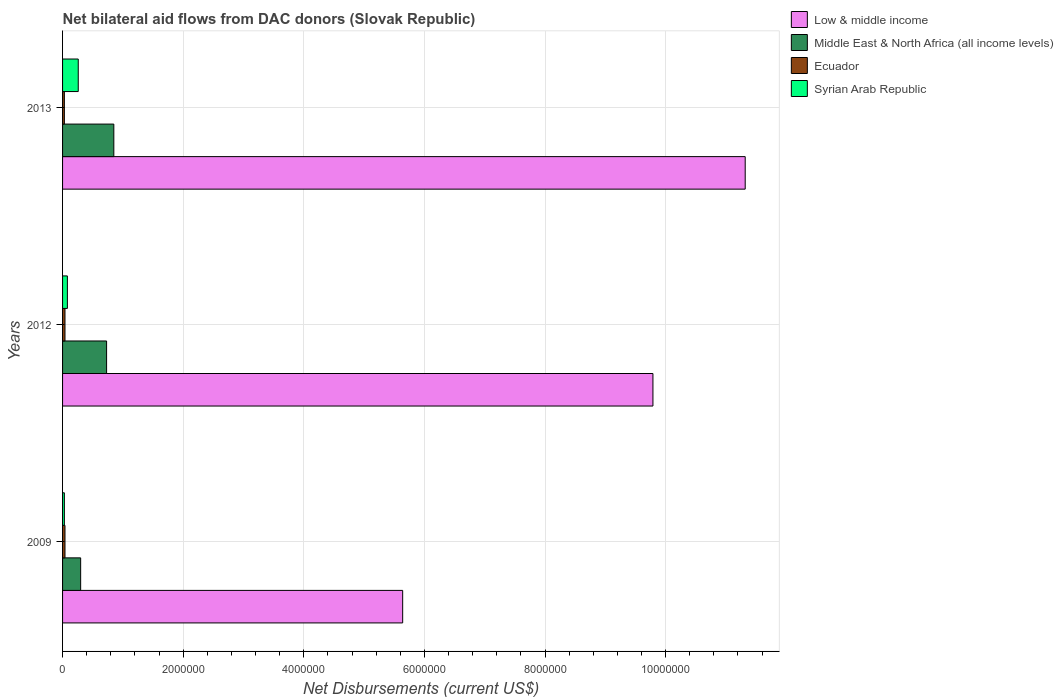How many different coloured bars are there?
Your answer should be compact. 4. Are the number of bars per tick equal to the number of legend labels?
Make the answer very short. Yes. How many bars are there on the 1st tick from the top?
Offer a very short reply. 4. What is the label of the 2nd group of bars from the top?
Your answer should be very brief. 2012. In how many cases, is the number of bars for a given year not equal to the number of legend labels?
Your answer should be very brief. 0. What is the net bilateral aid flows in Low & middle income in 2009?
Provide a short and direct response. 5.64e+06. Across all years, what is the minimum net bilateral aid flows in Syrian Arab Republic?
Make the answer very short. 3.00e+04. What is the total net bilateral aid flows in Ecuador in the graph?
Offer a terse response. 1.10e+05. What is the difference between the net bilateral aid flows in Syrian Arab Republic in 2009 and that in 2013?
Offer a terse response. -2.30e+05. What is the average net bilateral aid flows in Ecuador per year?
Provide a short and direct response. 3.67e+04. In the year 2012, what is the difference between the net bilateral aid flows in Ecuador and net bilateral aid flows in Middle East & North Africa (all income levels)?
Ensure brevity in your answer.  -6.90e+05. What is the ratio of the net bilateral aid flows in Ecuador in 2009 to that in 2012?
Provide a succinct answer. 1. Is the difference between the net bilateral aid flows in Ecuador in 2009 and 2012 greater than the difference between the net bilateral aid flows in Middle East & North Africa (all income levels) in 2009 and 2012?
Your answer should be very brief. Yes. What is the difference between the highest and the second highest net bilateral aid flows in Low & middle income?
Provide a succinct answer. 1.53e+06. What is the difference between the highest and the lowest net bilateral aid flows in Low & middle income?
Give a very brief answer. 5.68e+06. Is the sum of the net bilateral aid flows in Low & middle income in 2009 and 2013 greater than the maximum net bilateral aid flows in Syrian Arab Republic across all years?
Your answer should be compact. Yes. What does the 1st bar from the top in 2013 represents?
Your response must be concise. Syrian Arab Republic. What does the 3rd bar from the bottom in 2009 represents?
Offer a terse response. Ecuador. What is the difference between two consecutive major ticks on the X-axis?
Your answer should be compact. 2.00e+06. Does the graph contain any zero values?
Offer a very short reply. No. How many legend labels are there?
Offer a very short reply. 4. How are the legend labels stacked?
Give a very brief answer. Vertical. What is the title of the graph?
Keep it short and to the point. Net bilateral aid flows from DAC donors (Slovak Republic). What is the label or title of the X-axis?
Provide a succinct answer. Net Disbursements (current US$). What is the label or title of the Y-axis?
Your answer should be very brief. Years. What is the Net Disbursements (current US$) in Low & middle income in 2009?
Provide a succinct answer. 5.64e+06. What is the Net Disbursements (current US$) of Syrian Arab Republic in 2009?
Provide a succinct answer. 3.00e+04. What is the Net Disbursements (current US$) in Low & middle income in 2012?
Your answer should be very brief. 9.79e+06. What is the Net Disbursements (current US$) in Middle East & North Africa (all income levels) in 2012?
Your answer should be compact. 7.30e+05. What is the Net Disbursements (current US$) of Low & middle income in 2013?
Offer a terse response. 1.13e+07. What is the Net Disbursements (current US$) of Middle East & North Africa (all income levels) in 2013?
Offer a very short reply. 8.50e+05. What is the Net Disbursements (current US$) in Syrian Arab Republic in 2013?
Provide a short and direct response. 2.60e+05. Across all years, what is the maximum Net Disbursements (current US$) in Low & middle income?
Provide a short and direct response. 1.13e+07. Across all years, what is the maximum Net Disbursements (current US$) of Middle East & North Africa (all income levels)?
Keep it short and to the point. 8.50e+05. Across all years, what is the minimum Net Disbursements (current US$) in Low & middle income?
Offer a very short reply. 5.64e+06. Across all years, what is the minimum Net Disbursements (current US$) in Middle East & North Africa (all income levels)?
Keep it short and to the point. 3.00e+05. What is the total Net Disbursements (current US$) in Low & middle income in the graph?
Your answer should be compact. 2.68e+07. What is the total Net Disbursements (current US$) in Middle East & North Africa (all income levels) in the graph?
Offer a terse response. 1.88e+06. What is the total Net Disbursements (current US$) in Syrian Arab Republic in the graph?
Offer a very short reply. 3.70e+05. What is the difference between the Net Disbursements (current US$) in Low & middle income in 2009 and that in 2012?
Offer a terse response. -4.15e+06. What is the difference between the Net Disbursements (current US$) in Middle East & North Africa (all income levels) in 2009 and that in 2012?
Your answer should be compact. -4.30e+05. What is the difference between the Net Disbursements (current US$) of Ecuador in 2009 and that in 2012?
Your answer should be very brief. 0. What is the difference between the Net Disbursements (current US$) in Low & middle income in 2009 and that in 2013?
Offer a terse response. -5.68e+06. What is the difference between the Net Disbursements (current US$) of Middle East & North Africa (all income levels) in 2009 and that in 2013?
Provide a short and direct response. -5.50e+05. What is the difference between the Net Disbursements (current US$) in Ecuador in 2009 and that in 2013?
Your response must be concise. 10000. What is the difference between the Net Disbursements (current US$) in Low & middle income in 2012 and that in 2013?
Give a very brief answer. -1.53e+06. What is the difference between the Net Disbursements (current US$) in Low & middle income in 2009 and the Net Disbursements (current US$) in Middle East & North Africa (all income levels) in 2012?
Make the answer very short. 4.91e+06. What is the difference between the Net Disbursements (current US$) in Low & middle income in 2009 and the Net Disbursements (current US$) in Ecuador in 2012?
Your response must be concise. 5.60e+06. What is the difference between the Net Disbursements (current US$) in Low & middle income in 2009 and the Net Disbursements (current US$) in Syrian Arab Republic in 2012?
Offer a terse response. 5.56e+06. What is the difference between the Net Disbursements (current US$) in Middle East & North Africa (all income levels) in 2009 and the Net Disbursements (current US$) in Syrian Arab Republic in 2012?
Make the answer very short. 2.20e+05. What is the difference between the Net Disbursements (current US$) in Low & middle income in 2009 and the Net Disbursements (current US$) in Middle East & North Africa (all income levels) in 2013?
Your answer should be compact. 4.79e+06. What is the difference between the Net Disbursements (current US$) of Low & middle income in 2009 and the Net Disbursements (current US$) of Ecuador in 2013?
Offer a terse response. 5.61e+06. What is the difference between the Net Disbursements (current US$) of Low & middle income in 2009 and the Net Disbursements (current US$) of Syrian Arab Republic in 2013?
Give a very brief answer. 5.38e+06. What is the difference between the Net Disbursements (current US$) in Middle East & North Africa (all income levels) in 2009 and the Net Disbursements (current US$) in Syrian Arab Republic in 2013?
Your response must be concise. 4.00e+04. What is the difference between the Net Disbursements (current US$) in Low & middle income in 2012 and the Net Disbursements (current US$) in Middle East & North Africa (all income levels) in 2013?
Ensure brevity in your answer.  8.94e+06. What is the difference between the Net Disbursements (current US$) of Low & middle income in 2012 and the Net Disbursements (current US$) of Ecuador in 2013?
Provide a short and direct response. 9.76e+06. What is the difference between the Net Disbursements (current US$) in Low & middle income in 2012 and the Net Disbursements (current US$) in Syrian Arab Republic in 2013?
Give a very brief answer. 9.53e+06. What is the difference between the Net Disbursements (current US$) of Middle East & North Africa (all income levels) in 2012 and the Net Disbursements (current US$) of Ecuador in 2013?
Your response must be concise. 7.00e+05. What is the difference between the Net Disbursements (current US$) in Ecuador in 2012 and the Net Disbursements (current US$) in Syrian Arab Republic in 2013?
Provide a succinct answer. -2.20e+05. What is the average Net Disbursements (current US$) in Low & middle income per year?
Offer a terse response. 8.92e+06. What is the average Net Disbursements (current US$) of Middle East & North Africa (all income levels) per year?
Ensure brevity in your answer.  6.27e+05. What is the average Net Disbursements (current US$) of Ecuador per year?
Offer a very short reply. 3.67e+04. What is the average Net Disbursements (current US$) of Syrian Arab Republic per year?
Provide a short and direct response. 1.23e+05. In the year 2009, what is the difference between the Net Disbursements (current US$) in Low & middle income and Net Disbursements (current US$) in Middle East & North Africa (all income levels)?
Give a very brief answer. 5.34e+06. In the year 2009, what is the difference between the Net Disbursements (current US$) of Low & middle income and Net Disbursements (current US$) of Ecuador?
Give a very brief answer. 5.60e+06. In the year 2009, what is the difference between the Net Disbursements (current US$) of Low & middle income and Net Disbursements (current US$) of Syrian Arab Republic?
Your answer should be compact. 5.61e+06. In the year 2009, what is the difference between the Net Disbursements (current US$) of Middle East & North Africa (all income levels) and Net Disbursements (current US$) of Syrian Arab Republic?
Make the answer very short. 2.70e+05. In the year 2009, what is the difference between the Net Disbursements (current US$) of Ecuador and Net Disbursements (current US$) of Syrian Arab Republic?
Ensure brevity in your answer.  10000. In the year 2012, what is the difference between the Net Disbursements (current US$) of Low & middle income and Net Disbursements (current US$) of Middle East & North Africa (all income levels)?
Your response must be concise. 9.06e+06. In the year 2012, what is the difference between the Net Disbursements (current US$) in Low & middle income and Net Disbursements (current US$) in Ecuador?
Ensure brevity in your answer.  9.75e+06. In the year 2012, what is the difference between the Net Disbursements (current US$) in Low & middle income and Net Disbursements (current US$) in Syrian Arab Republic?
Provide a succinct answer. 9.71e+06. In the year 2012, what is the difference between the Net Disbursements (current US$) in Middle East & North Africa (all income levels) and Net Disbursements (current US$) in Ecuador?
Your response must be concise. 6.90e+05. In the year 2012, what is the difference between the Net Disbursements (current US$) of Middle East & North Africa (all income levels) and Net Disbursements (current US$) of Syrian Arab Republic?
Your response must be concise. 6.50e+05. In the year 2012, what is the difference between the Net Disbursements (current US$) of Ecuador and Net Disbursements (current US$) of Syrian Arab Republic?
Provide a succinct answer. -4.00e+04. In the year 2013, what is the difference between the Net Disbursements (current US$) of Low & middle income and Net Disbursements (current US$) of Middle East & North Africa (all income levels)?
Your response must be concise. 1.05e+07. In the year 2013, what is the difference between the Net Disbursements (current US$) of Low & middle income and Net Disbursements (current US$) of Ecuador?
Provide a succinct answer. 1.13e+07. In the year 2013, what is the difference between the Net Disbursements (current US$) of Low & middle income and Net Disbursements (current US$) of Syrian Arab Republic?
Keep it short and to the point. 1.11e+07. In the year 2013, what is the difference between the Net Disbursements (current US$) of Middle East & North Africa (all income levels) and Net Disbursements (current US$) of Ecuador?
Offer a very short reply. 8.20e+05. In the year 2013, what is the difference between the Net Disbursements (current US$) of Middle East & North Africa (all income levels) and Net Disbursements (current US$) of Syrian Arab Republic?
Give a very brief answer. 5.90e+05. What is the ratio of the Net Disbursements (current US$) of Low & middle income in 2009 to that in 2012?
Your answer should be compact. 0.58. What is the ratio of the Net Disbursements (current US$) in Middle East & North Africa (all income levels) in 2009 to that in 2012?
Offer a very short reply. 0.41. What is the ratio of the Net Disbursements (current US$) of Ecuador in 2009 to that in 2012?
Provide a succinct answer. 1. What is the ratio of the Net Disbursements (current US$) in Syrian Arab Republic in 2009 to that in 2012?
Keep it short and to the point. 0.38. What is the ratio of the Net Disbursements (current US$) in Low & middle income in 2009 to that in 2013?
Your response must be concise. 0.5. What is the ratio of the Net Disbursements (current US$) of Middle East & North Africa (all income levels) in 2009 to that in 2013?
Offer a very short reply. 0.35. What is the ratio of the Net Disbursements (current US$) of Ecuador in 2009 to that in 2013?
Your response must be concise. 1.33. What is the ratio of the Net Disbursements (current US$) of Syrian Arab Republic in 2009 to that in 2013?
Ensure brevity in your answer.  0.12. What is the ratio of the Net Disbursements (current US$) in Low & middle income in 2012 to that in 2013?
Keep it short and to the point. 0.86. What is the ratio of the Net Disbursements (current US$) in Middle East & North Africa (all income levels) in 2012 to that in 2013?
Your answer should be very brief. 0.86. What is the ratio of the Net Disbursements (current US$) in Ecuador in 2012 to that in 2013?
Make the answer very short. 1.33. What is the ratio of the Net Disbursements (current US$) of Syrian Arab Republic in 2012 to that in 2013?
Your answer should be compact. 0.31. What is the difference between the highest and the second highest Net Disbursements (current US$) in Low & middle income?
Offer a very short reply. 1.53e+06. What is the difference between the highest and the second highest Net Disbursements (current US$) in Ecuador?
Your answer should be compact. 0. What is the difference between the highest and the second highest Net Disbursements (current US$) of Syrian Arab Republic?
Provide a short and direct response. 1.80e+05. What is the difference between the highest and the lowest Net Disbursements (current US$) in Low & middle income?
Provide a succinct answer. 5.68e+06. What is the difference between the highest and the lowest Net Disbursements (current US$) of Middle East & North Africa (all income levels)?
Ensure brevity in your answer.  5.50e+05. What is the difference between the highest and the lowest Net Disbursements (current US$) in Ecuador?
Keep it short and to the point. 10000. What is the difference between the highest and the lowest Net Disbursements (current US$) in Syrian Arab Republic?
Offer a terse response. 2.30e+05. 